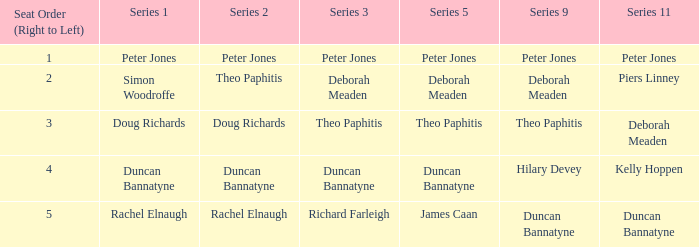For a series 3 starring deborah meaden, how many right-to-left seat orders are there? 1.0. 